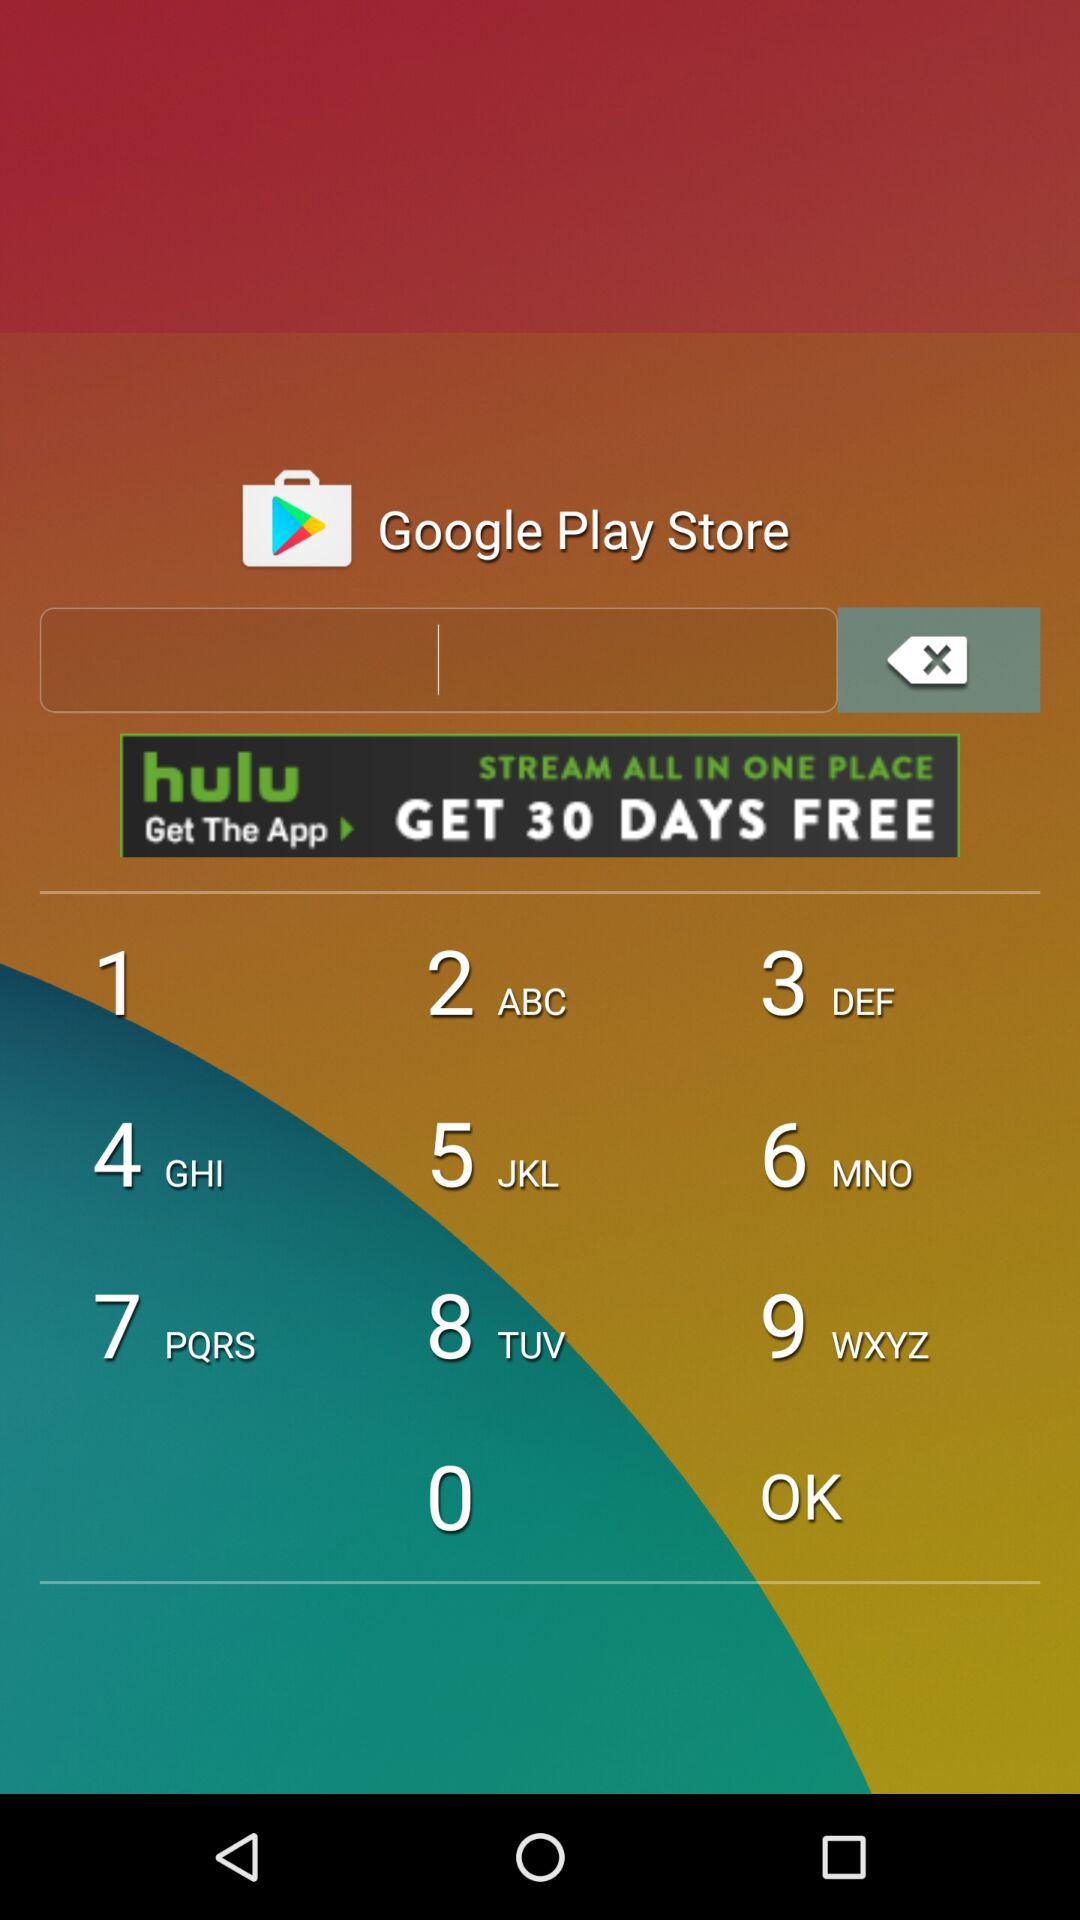At which page are we right now? You are at the first page. 